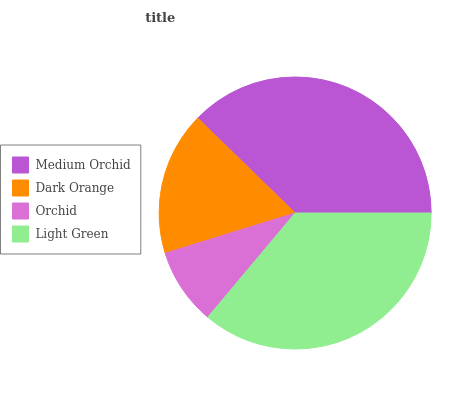Is Orchid the minimum?
Answer yes or no. Yes. Is Medium Orchid the maximum?
Answer yes or no. Yes. Is Dark Orange the minimum?
Answer yes or no. No. Is Dark Orange the maximum?
Answer yes or no. No. Is Medium Orchid greater than Dark Orange?
Answer yes or no. Yes. Is Dark Orange less than Medium Orchid?
Answer yes or no. Yes. Is Dark Orange greater than Medium Orchid?
Answer yes or no. No. Is Medium Orchid less than Dark Orange?
Answer yes or no. No. Is Light Green the high median?
Answer yes or no. Yes. Is Dark Orange the low median?
Answer yes or no. Yes. Is Orchid the high median?
Answer yes or no. No. Is Light Green the low median?
Answer yes or no. No. 